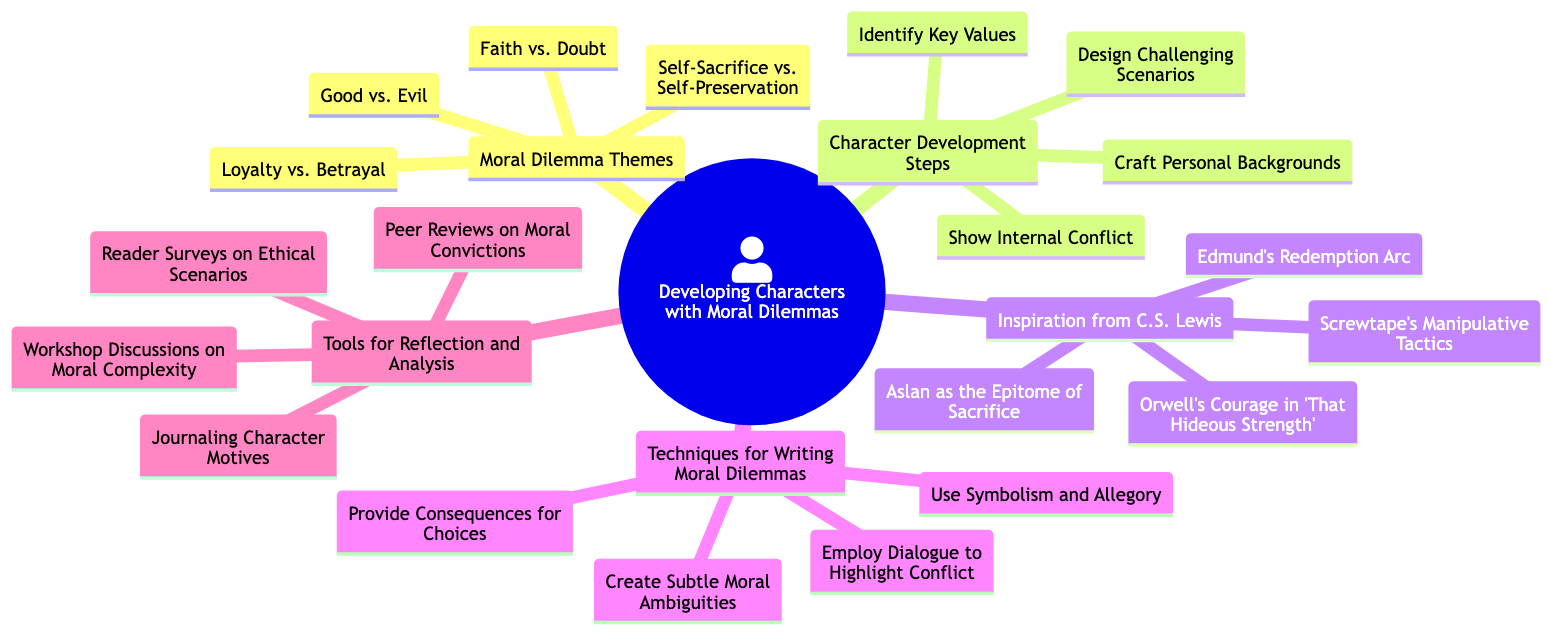What are the four main themes of moral dilemmas listed? The diagram illustrates four main themes under "Moral Dilemma Themes": Good vs. Evil, Faith vs. Doubt, Self-Sacrifice vs. Self-Preservation, and Loyalty vs. Betrayal.
Answer: Good vs. Evil, Faith vs. Doubt, Self-Sacrifice vs. Self-Preservation, Loyalty vs. Betrayal How many steps are in the character development section? The "Character Development Steps" node contains four elements: Identify Key Values, Craft Personal Backgrounds, Design Challenging Scenarios, and Show Internal Conflict. Therefore, there are four steps.
Answer: 4 Which character represents sacrifice in C.S. Lewis's work? The "Inspiration from C.S. Lewis" section lists Aslan as the epitome of sacrifice, showing his significance in representing self-sacrifice within the narrative.
Answer: Aslan Name one technique for writing moral dilemmas. The "Techniques for Writing Moral Dilemmas" section outlines multiple techniques, one of which is "Use Symbolism and Allegory", indicating its relevance in constructing moral dilemmas in writing.
Answer: Use Symbolism and Allegory What are the tools for reflection and analysis described? The "Tools for Reflection and Analysis" section includes four elements: Journaling Character Motives, Peer Reviews on Moral Convictions, Reader Surveys on Ethical Scenarios, and Workshop Discussions on Moral Complexity, representing useful methods for exploring moral dilemmas.
Answer: Journaling Character Motives, Peer Reviews on Moral Convictions, Reader Surveys on Ethical Scenarios, Workshop Discussions on Moral Complexity Which moral dilemma theme involves loyalty and betrayal? The "Moral Dilemma Themes" lists "Loyalty vs. Betrayal" explicitly as one of the main themes, indicating the tension between these two opposing concepts in character development.
Answer: Loyalty vs. Betrayal How many elements are in the "Inspiration from C.S. Lewis" section? There are four listed elements in the "Inspiration from C.S. Lewis" section: Aslan as the Epitome of Sacrifice, Edmund's Redemption Arc, Screwtape's Manipulative Tactics, and Orwell's Courage in 'That Hideous Strength.' Thus, there are four elements.
Answer: 4 What is a consequence of choices according to the diagram? According to the "Techniques for Writing Moral Dilemmas," one aspect of creating moral dilemmas involves "Provide Consequences for Choices," emphasizing the importance of demonstrating outcomes based on characters' decisions.
Answer: Provide Consequences for Choices 